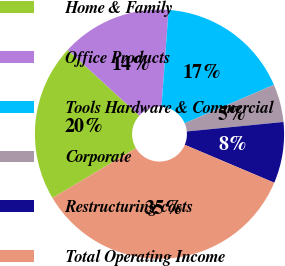Convert chart to OTSL. <chart><loc_0><loc_0><loc_500><loc_500><pie_chart><fcel>Home & Family<fcel>Office Products<fcel>Tools Hardware & Commercial<fcel>Corporate<fcel>Restructuring costs<fcel>Total Operating Income<nl><fcel>20.38%<fcel>14.35%<fcel>17.36%<fcel>4.92%<fcel>7.93%<fcel>35.07%<nl></chart> 